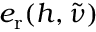<formula> <loc_0><loc_0><loc_500><loc_500>e _ { r } ( h , \tilde { \nu } )</formula> 